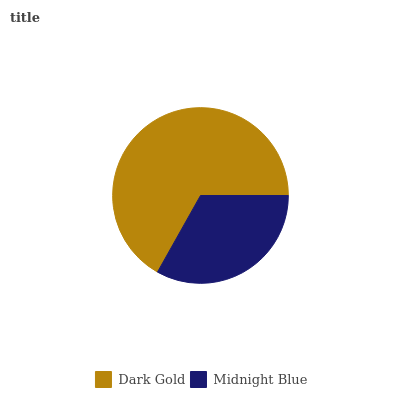Is Midnight Blue the minimum?
Answer yes or no. Yes. Is Dark Gold the maximum?
Answer yes or no. Yes. Is Midnight Blue the maximum?
Answer yes or no. No. Is Dark Gold greater than Midnight Blue?
Answer yes or no. Yes. Is Midnight Blue less than Dark Gold?
Answer yes or no. Yes. Is Midnight Blue greater than Dark Gold?
Answer yes or no. No. Is Dark Gold less than Midnight Blue?
Answer yes or no. No. Is Dark Gold the high median?
Answer yes or no. Yes. Is Midnight Blue the low median?
Answer yes or no. Yes. Is Midnight Blue the high median?
Answer yes or no. No. Is Dark Gold the low median?
Answer yes or no. No. 